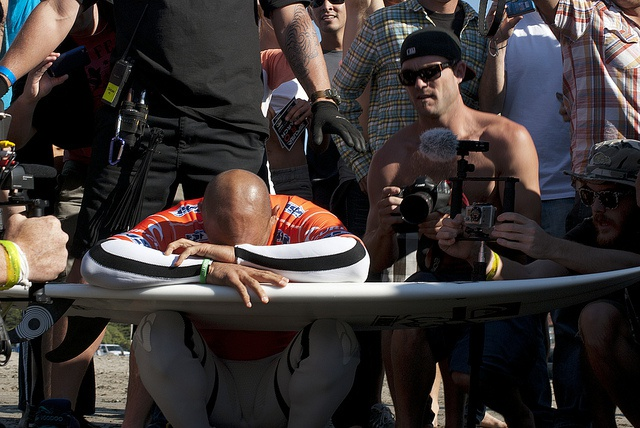Describe the objects in this image and their specific colors. I can see people in tan, black, and gray tones, people in tan, black, white, maroon, and brown tones, people in tan, black, and gray tones, surfboard in tan, black, gray, and lightgray tones, and people in tan, black, and gray tones in this image. 